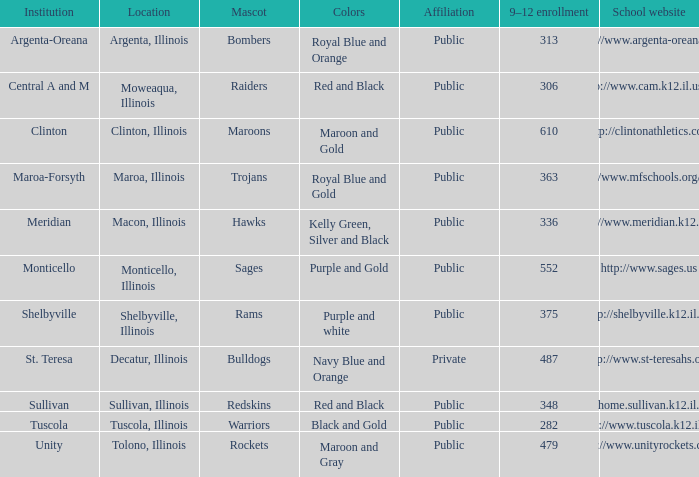How many different combinations of team colors are there in all the schools in Maroa, Illinois? 1.0. 